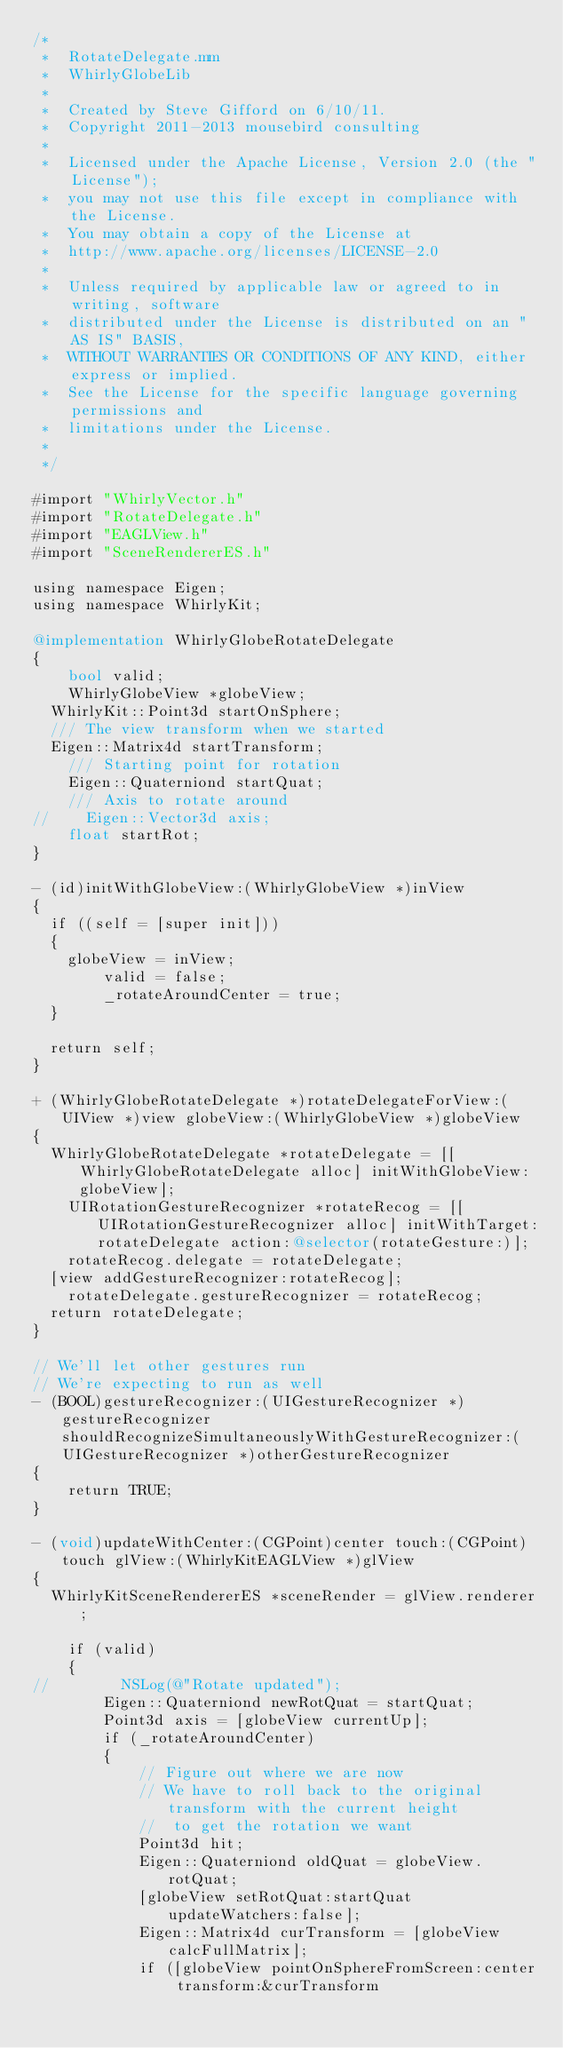<code> <loc_0><loc_0><loc_500><loc_500><_ObjectiveC_>/*
 *  RotateDelegate.mm
 *  WhirlyGlobeLib
 *
 *  Created by Steve Gifford on 6/10/11.
 *  Copyright 2011-2013 mousebird consulting
 *
 *  Licensed under the Apache License, Version 2.0 (the "License");
 *  you may not use this file except in compliance with the License.
 *  You may obtain a copy of the License at
 *  http://www.apache.org/licenses/LICENSE-2.0
 *
 *  Unless required by applicable law or agreed to in writing, software
 *  distributed under the License is distributed on an "AS IS" BASIS,
 *  WITHOUT WARRANTIES OR CONDITIONS OF ANY KIND, either express or implied.
 *  See the License for the specific language governing permissions and
 *  limitations under the License.
 *
 */

#import "WhirlyVector.h"
#import "RotateDelegate.h"
#import "EAGLView.h"
#import "SceneRendererES.h"

using namespace Eigen;
using namespace WhirlyKit;

@implementation WhirlyGlobeRotateDelegate
{
    bool valid;
    WhirlyGlobeView *globeView;
	WhirlyKit::Point3d startOnSphere;
	/// The view transform when we started
	Eigen::Matrix4d startTransform;
    /// Starting point for rotation
    Eigen::Quaterniond startQuat;
    /// Axis to rotate around
//    Eigen::Vector3d axis;
    float startRot;
}

- (id)initWithGlobeView:(WhirlyGlobeView *)inView
{
	if ((self = [super init]))
	{
		globeView = inView;
        valid = false;
        _rotateAroundCenter = true;
	}
	
	return self;
}

+ (WhirlyGlobeRotateDelegate *)rotateDelegateForView:(UIView *)view globeView:(WhirlyGlobeView *)globeView
{
	WhirlyGlobeRotateDelegate *rotateDelegate = [[WhirlyGlobeRotateDelegate alloc] initWithGlobeView:globeView];
    UIRotationGestureRecognizer *rotateRecog = [[UIRotationGestureRecognizer alloc] initWithTarget:rotateDelegate action:@selector(rotateGesture:)];
    rotateRecog.delegate = rotateDelegate;
	[view addGestureRecognizer:rotateRecog];
    rotateDelegate.gestureRecognizer = rotateRecog;
	return rotateDelegate;
}

// We'll let other gestures run
// We're expecting to run as well
- (BOOL)gestureRecognizer:(UIGestureRecognizer *)gestureRecognizer shouldRecognizeSimultaneouslyWithGestureRecognizer:(UIGestureRecognizer *)otherGestureRecognizer
{
    return TRUE;
}

- (void)updateWithCenter:(CGPoint)center touch:(CGPoint)touch glView:(WhirlyKitEAGLView *)glView
{
	WhirlyKitSceneRendererES *sceneRender = glView.renderer;

    if (valid)
    {
//        NSLog(@"Rotate updated");
        Eigen::Quaterniond newRotQuat = startQuat;
        Point3d axis = [globeView currentUp];
        if (_rotateAroundCenter)
        {
            // Figure out where we are now
            // We have to roll back to the original transform with the current height
            //  to get the rotation we want
            Point3d hit;
            Eigen::Quaterniond oldQuat = globeView.rotQuat;
            [globeView setRotQuat:startQuat updateWatchers:false];
            Eigen::Matrix4d curTransform = [globeView calcFullMatrix];
            if ([globeView pointOnSphereFromScreen:center transform:&curTransform</code> 